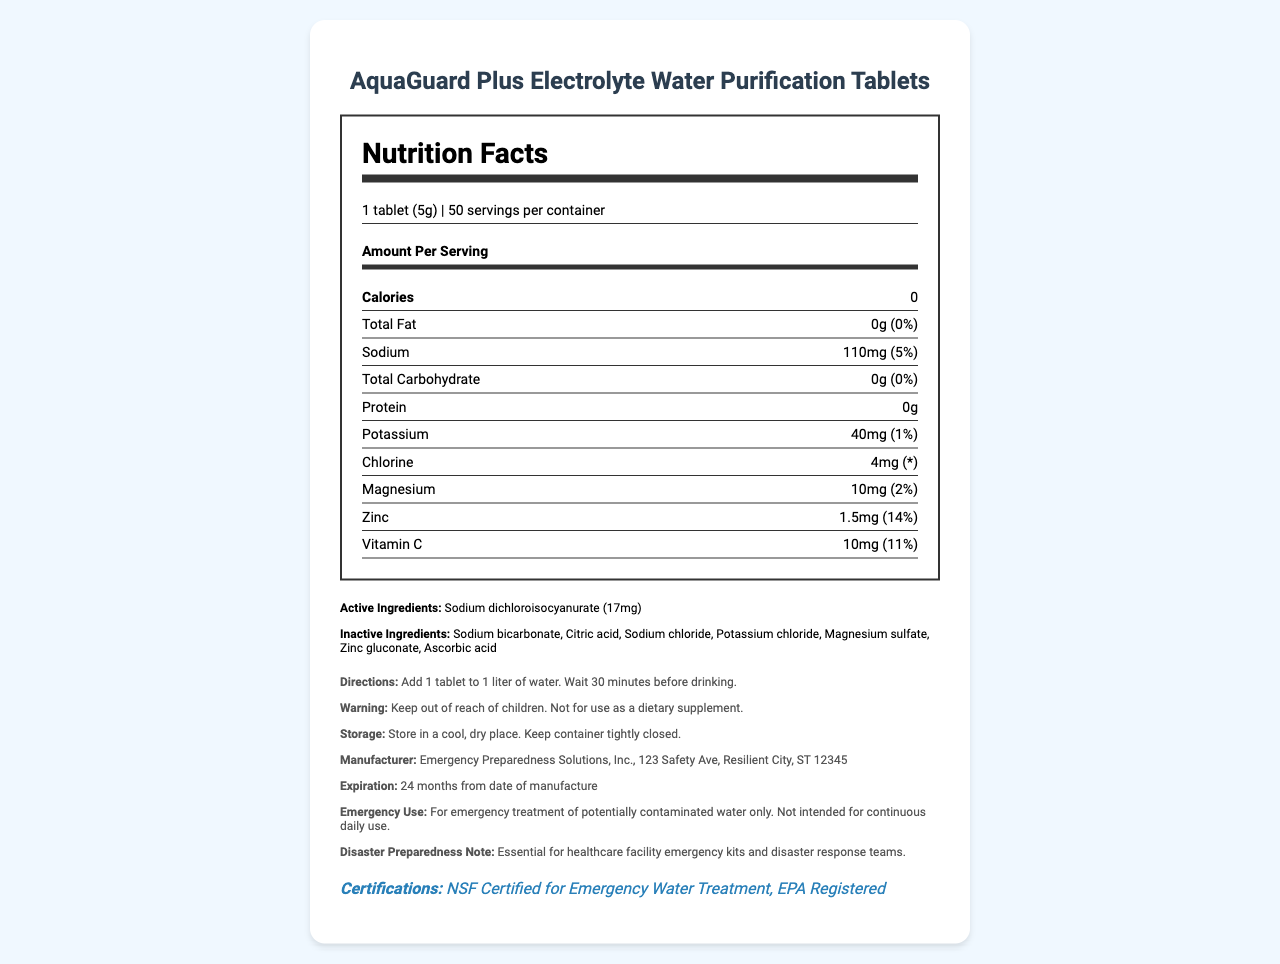what is the product name? The product name is given at the very top of the document.
Answer: AquaGuard Plus Electrolyte Water Purification Tablets how many servings are in the container? The document states that there are 50 servings per container under the serving information section.
Answer: 50 servings how many calories are in each serving? The nutrient row for calories indicates that each serving contains 0 calories.
Answer: 0 calories what is the amount of sodium per serving? The nutrient row for sodium specifies an amount of 110mg per serving.
Answer: 110mg what is the daily value percentage of zinc per serving? The nutrient row for zinc indicates that the daily value percentage for zinc is 14%.
Answer: 14% what is the serving size for this product? A. 2 tablets (10g) B. 1 tablet (5g) C. 1/2 tablet (2.5g) The serving size mentioned in the document is 1 tablet (5g).
Answer: B what is the expiration period of the product? A. 12 months from date of manufacture B. 18 months from date of manufacture C. 24 months from date of manufacture D. 36 months from date of manufacture The expiration period is 24 months from the date of manufacture, as stated under the expiration information.
Answer: C does the product contain any protein? The nutrient row for protein specifies that there is 0g of protein per serving, indicating that the product contains no protein.
Answer: No summarize the main idea of the document The document aims to inform users about the nutritional content, safe usage, and storage of the water purification tablets, emphasizing their utility in emergencies and disaster preparedness.
Answer: The document provides comprehensive nutritional information, ingredients, usage directions, warnings, storage instructions, manufacturer details, expiration date, emergency use statement, disaster preparedness note, and certifications for AquaGuard Plus Electrolyte Water Purification Tablets. what is the purpose of sodium dichloroisocyanurate in the product? The document lists sodium dichloroisocyanurate as an active ingredient but does not explain its specific purpose.
Answer: Not enough information 